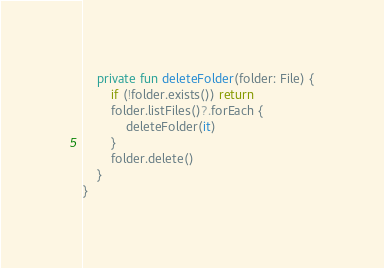<code> <loc_0><loc_0><loc_500><loc_500><_Kotlin_>
	private fun deleteFolder(folder: File) {
		if (!folder.exists()) return
		folder.listFiles()?.forEach {
			deleteFolder(it)
		}
		folder.delete()
	}
}
</code> 